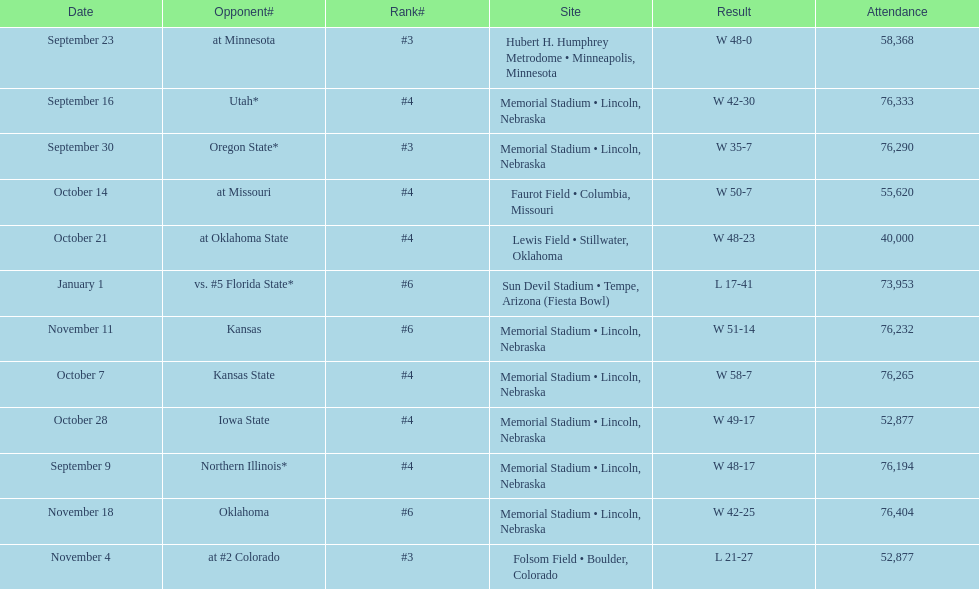On average how many times was w listed as the result? 10. 